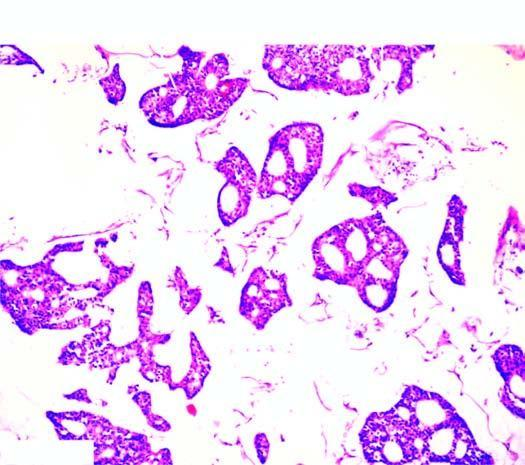re the opened up chambers of the heart seen as clusters floating in pools of abundant mucin?
Answer the question using a single word or phrase. No 